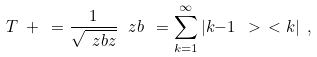<formula> <loc_0><loc_0><loc_500><loc_500>T ^ { \ } + \ = \frac { 1 } { \sqrt { \ z b z } } \, \ z b \ = \sum _ { k = 1 } ^ { \infty } | k { - } 1 \ > \ < k | \ ,</formula> 